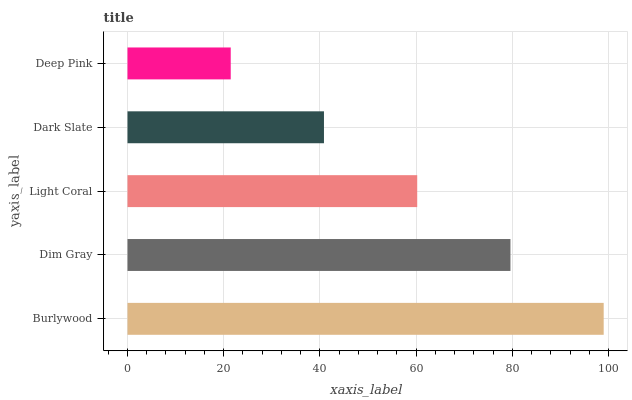Is Deep Pink the minimum?
Answer yes or no. Yes. Is Burlywood the maximum?
Answer yes or no. Yes. Is Dim Gray the minimum?
Answer yes or no. No. Is Dim Gray the maximum?
Answer yes or no. No. Is Burlywood greater than Dim Gray?
Answer yes or no. Yes. Is Dim Gray less than Burlywood?
Answer yes or no. Yes. Is Dim Gray greater than Burlywood?
Answer yes or no. No. Is Burlywood less than Dim Gray?
Answer yes or no. No. Is Light Coral the high median?
Answer yes or no. Yes. Is Light Coral the low median?
Answer yes or no. Yes. Is Dim Gray the high median?
Answer yes or no. No. Is Dark Slate the low median?
Answer yes or no. No. 